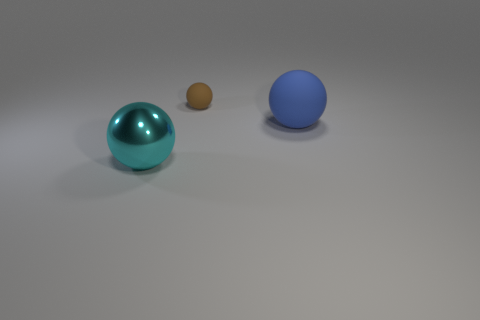How many other things are the same shape as the brown rubber object?
Provide a short and direct response. 2. Is the large metallic object the same shape as the small matte thing?
Offer a terse response. Yes. Are there any tiny brown matte balls in front of the big blue rubber thing?
Provide a succinct answer. No. How many objects are metal spheres or large blue shiny balls?
Offer a terse response. 1. What number of other objects are the same size as the brown matte object?
Offer a very short reply. 0. How many big balls are both on the left side of the blue rubber ball and behind the large cyan sphere?
Your answer should be very brief. 0. Does the rubber sphere in front of the small matte sphere have the same size as the object that is left of the tiny brown thing?
Ensure brevity in your answer.  Yes. What is the size of the object to the left of the small brown rubber sphere?
Offer a terse response. Large. How many things are either rubber things to the left of the large blue matte sphere or matte balls in front of the brown sphere?
Provide a succinct answer. 2. Are there any other things that have the same color as the big matte sphere?
Make the answer very short. No. 